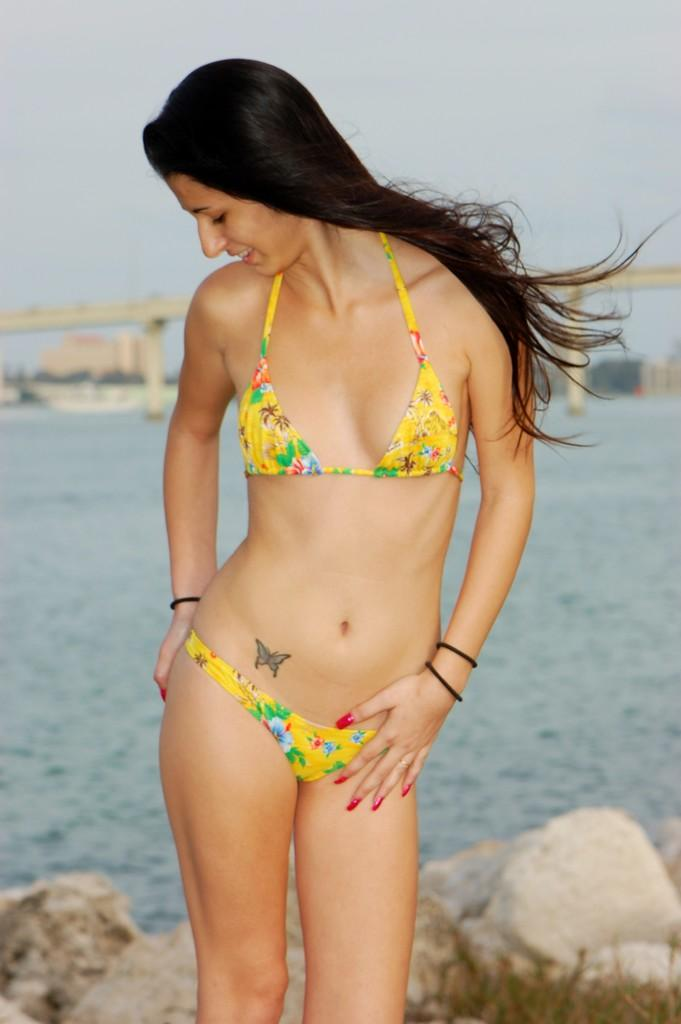What is the main subject of the image? There is a woman standing in the image. Where is the woman standing? The woman is standing on the ground. What can be seen in the background of the image? There is a bridge, the sky, water, buildings, and rocks in the background of the image. What type of light is being used to illuminate the circle in the image? There is no circle or light present in the image. 